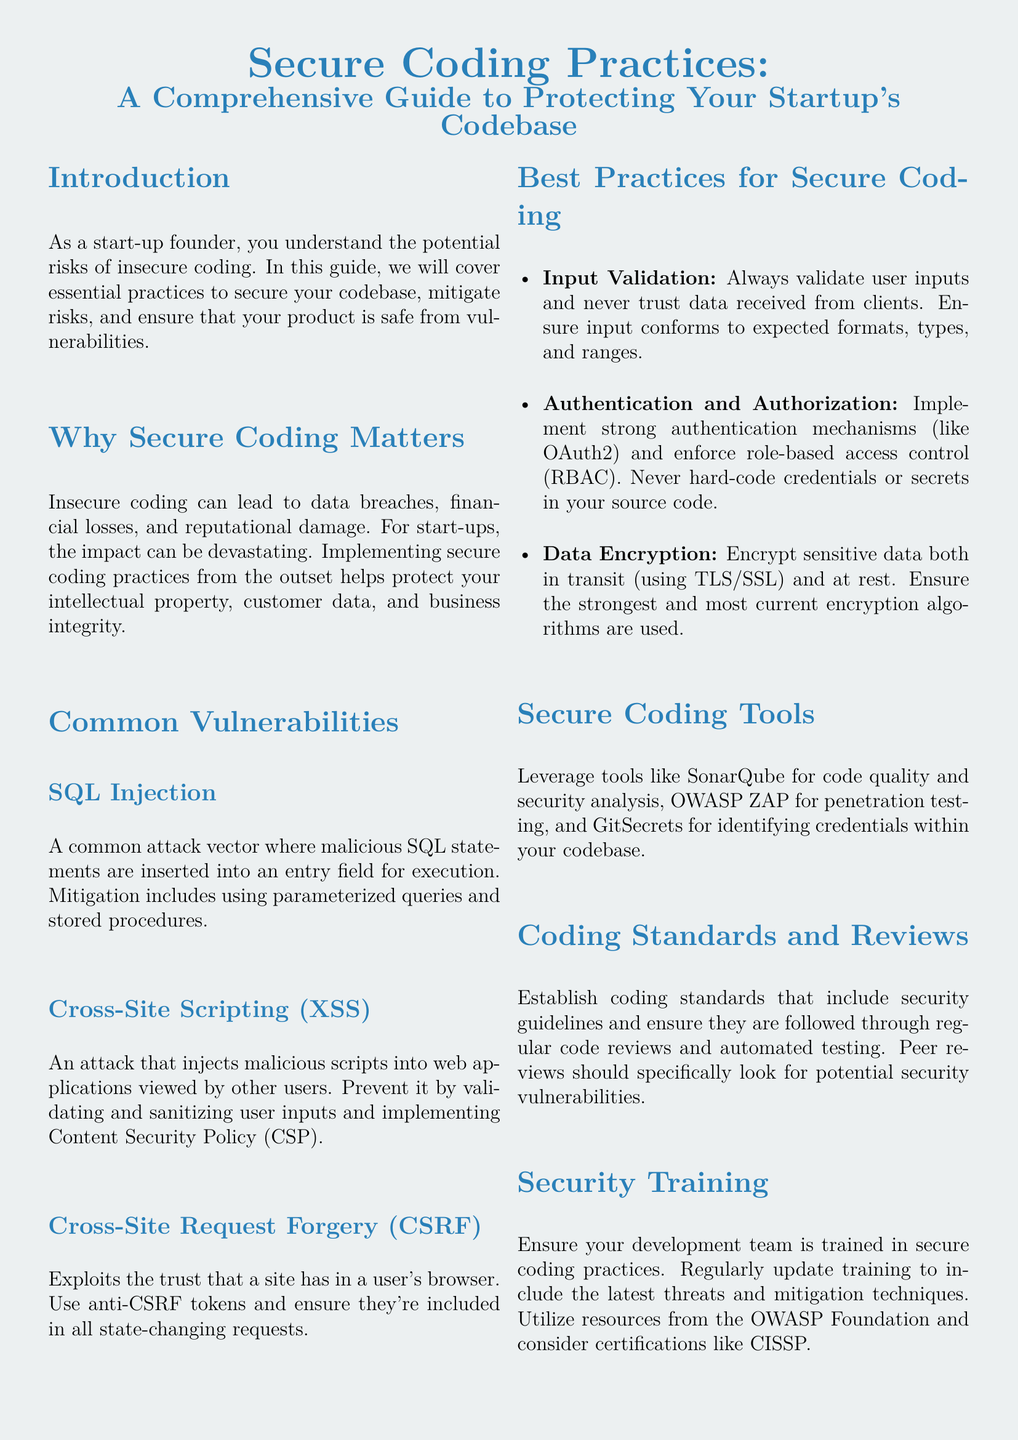What is the title of the guide? The title of the guide is prominently stated at the beginning of the document.
Answer: Secure Coding Practices: A Comprehensive Guide to Protecting Your Startup's Codebase What is one common vulnerability mentioned? The document lists specific vulnerabilities in the section on common vulnerabilities.
Answer: SQL Injection What are the three best practices for secure coding? The best practices are outlined in a list under the best practices section of the document.
Answer: Input Validation, Authentication and Authorization, Data Encryption Which tool is recommended for code quality analysis? The document mentions specific tools that can be utilized for secure coding practices.
Answer: SonarQube Why is secure coding important for startups? The importance of secure coding is discussed in the introduction, emphasizing the risks for startups.
Answer: Data breaches, financial losses, and reputational damage What does CSRF stand for? The abbreviation is defined in the section describing common vulnerabilities.
Answer: Cross-Site Request Forgery What recommendation is made regarding security training? The document emphasizes the need for regular updates in training for development teams.
Answer: Regularly update training to include the latest threats and mitigation techniques How should sensitive data be handled? The section on data encryption provides guidance on handling sensitive data.
Answer: Encrypt sensitive data both in transit and at rest 